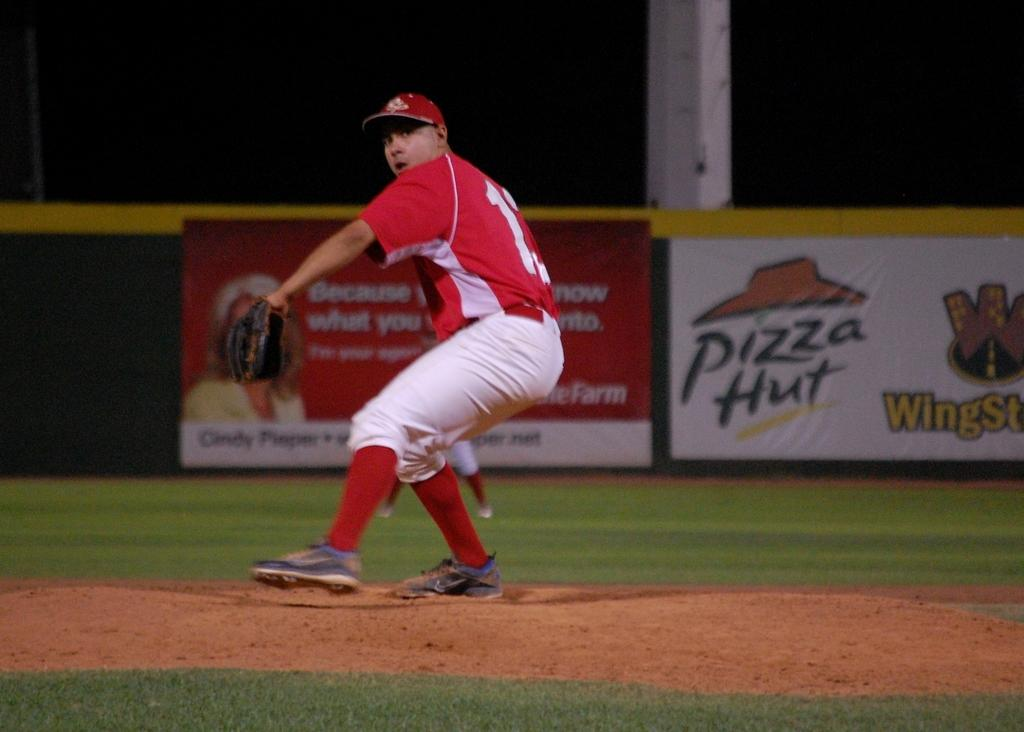<image>
Create a compact narrative representing the image presented. A baseball player is about to throw the ball and an ad for Pizza Hut Wingstreet is behind him. 